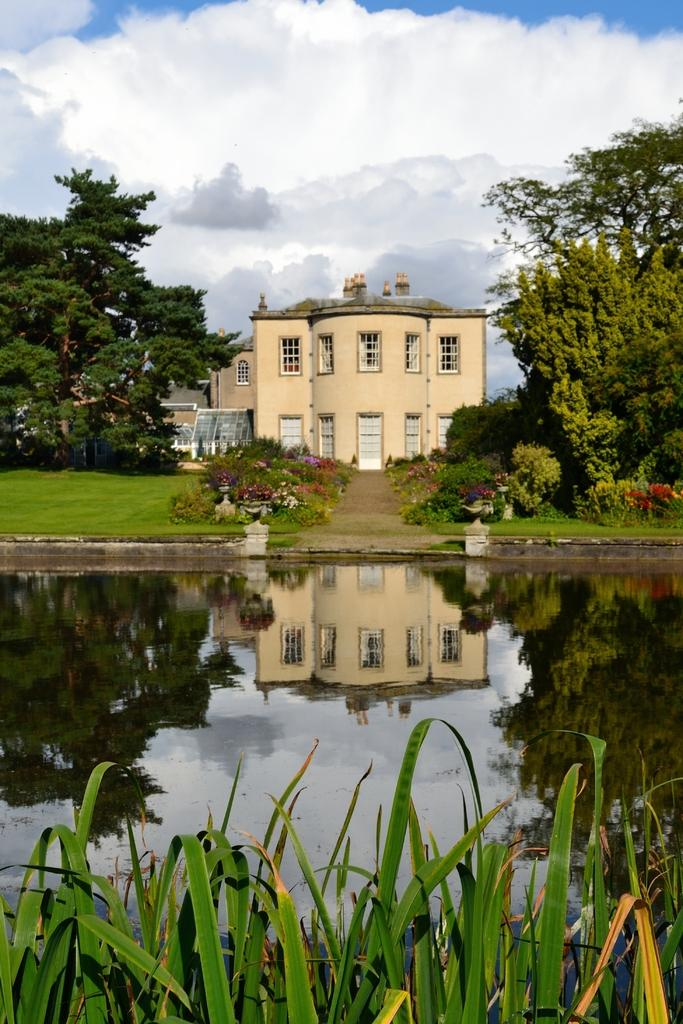What type of water body is present in the image? There is a pond in the image. What type of vegetation can be seen on the ground? There is grass on the ground. What other types of vegetation are present in the image? There are plants and trees in the image. What can be seen in the background of the image? There is a building and the sky visible in the background of the image. What is the condition of the sky in the image? The sky has clouds in the image. What type of yam is being used as a payment method in the image? There is no yam or payment method present in the image. What type of appliance can be seen in the image? There is no appliance present in the image. 